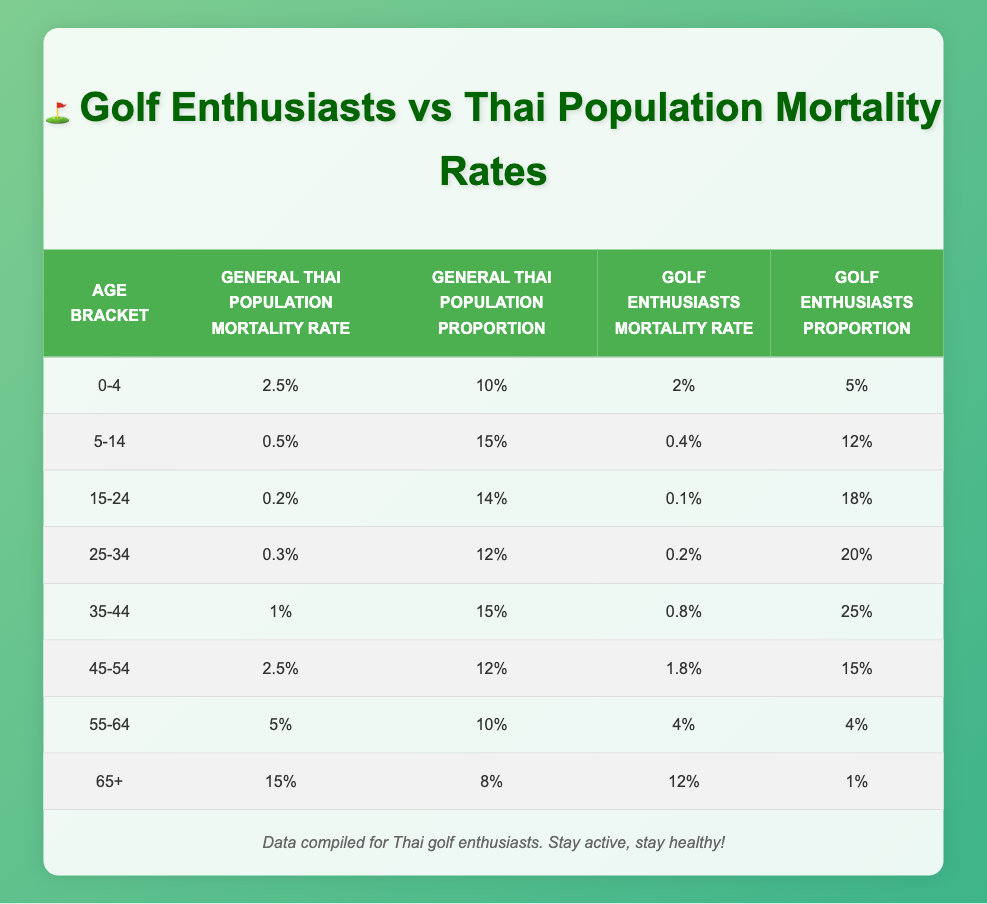What is the mortality rate for the general Thai population in the age bracket 25-34? Referring to the table, the mortality rate in that age bracket is listed directly under the "General Thai Population Mortality Rate" column for 25-34, which is 0.3%.
Answer: 0.3% What is the mortality rate for golf enthusiasts aged 55-64? In the table, the value under the "Golf Enthusiasts Mortality Rate" for the age bracket 55-64 is directly stated, which is 0.04 or 4%.
Answer: 4% Which age bracket has the highest mortality rate for the general Thai population? By examining the "General Thai Population Mortality Rate" column, we can see that the age bracket 65+ has the highest value at 15%.
Answer: 15% Is the mortality rate for golf enthusiasts higher than for the general Thai population in the age bracket 45-54? Comparing the values, the mortality rate for golf enthusiasts in the 45-54 age bracket is 1.8% and for the general population, it is 2.5%. Since 1.8% is less than 2.5%, the answer is no.
Answer: No What is the total population proportion for the age bracket 15-24 among golf enthusiasts? According to the table, the population proportion for golf enthusiasts in the age bracket 15-24 is 0.18 or 18%, with no calculations needed.
Answer: 18% Calculate the difference in mortality rates for the age bracket 35-44 between the general Thai population and golf enthusiasts. The mortality rate for the general Thai population in this age bracket is 1.0% (0.010), and for golf enthusiasts, it is 0.8% (0.008). The difference is 1.0% - 0.8% = 0.2%.
Answer: 0.2% What is the average mortality rate for golf enthusiasts across all age brackets? To find the average, sum the mortality rates for all age brackets for golf enthusiasts: (0.02 + 0.004 + 0.001 + 0.002 + 0.008 + 0.018 + 0.04 + 0.12) = 0.195. There are 8 age brackets, so the average is 0.195 / 8 = 0.024375 or approximately 0.0244.
Answer: 0.0244 Do golf enthusiasts aged 65+ have a higher mortality rate than those aged 55-64? Looking at the table, the mortality rate for golf enthusiasts aged 65+ is 0.12 (12%) and for those aged 55-64, it is 0.04 (4%). Since 0.12 is greater than 0.04, the answer is yes.
Answer: Yes What is the total population proportion of the age bracket 0-4 in the general Thai population? The population proportion for the age bracket 0-4 in the table is clearly stated as 10%.
Answer: 10% 